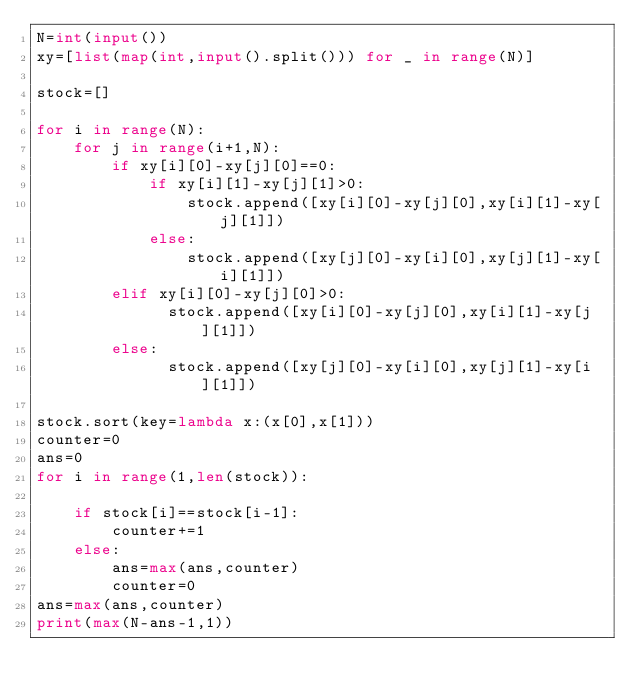<code> <loc_0><loc_0><loc_500><loc_500><_Python_>N=int(input())
xy=[list(map(int,input().split())) for _ in range(N)]

stock=[]

for i in range(N):
    for j in range(i+1,N):
        if xy[i][0]-xy[j][0]==0:
            if xy[i][1]-xy[j][1]>0:
                stock.append([xy[i][0]-xy[j][0],xy[i][1]-xy[j][1]])
            else:
                stock.append([xy[j][0]-xy[i][0],xy[j][1]-xy[i][1]])
        elif xy[i][0]-xy[j][0]>0:
              stock.append([xy[i][0]-xy[j][0],xy[i][1]-xy[j][1]])
        else:
              stock.append([xy[j][0]-xy[i][0],xy[j][1]-xy[i][1]])

stock.sort(key=lambda x:(x[0],x[1]))
counter=0
ans=0
for i in range(1,len(stock)):

    if stock[i]==stock[i-1]:
        counter+=1
    else:
        ans=max(ans,counter)
        counter=0
ans=max(ans,counter)
print(max(N-ans-1,1))</code> 